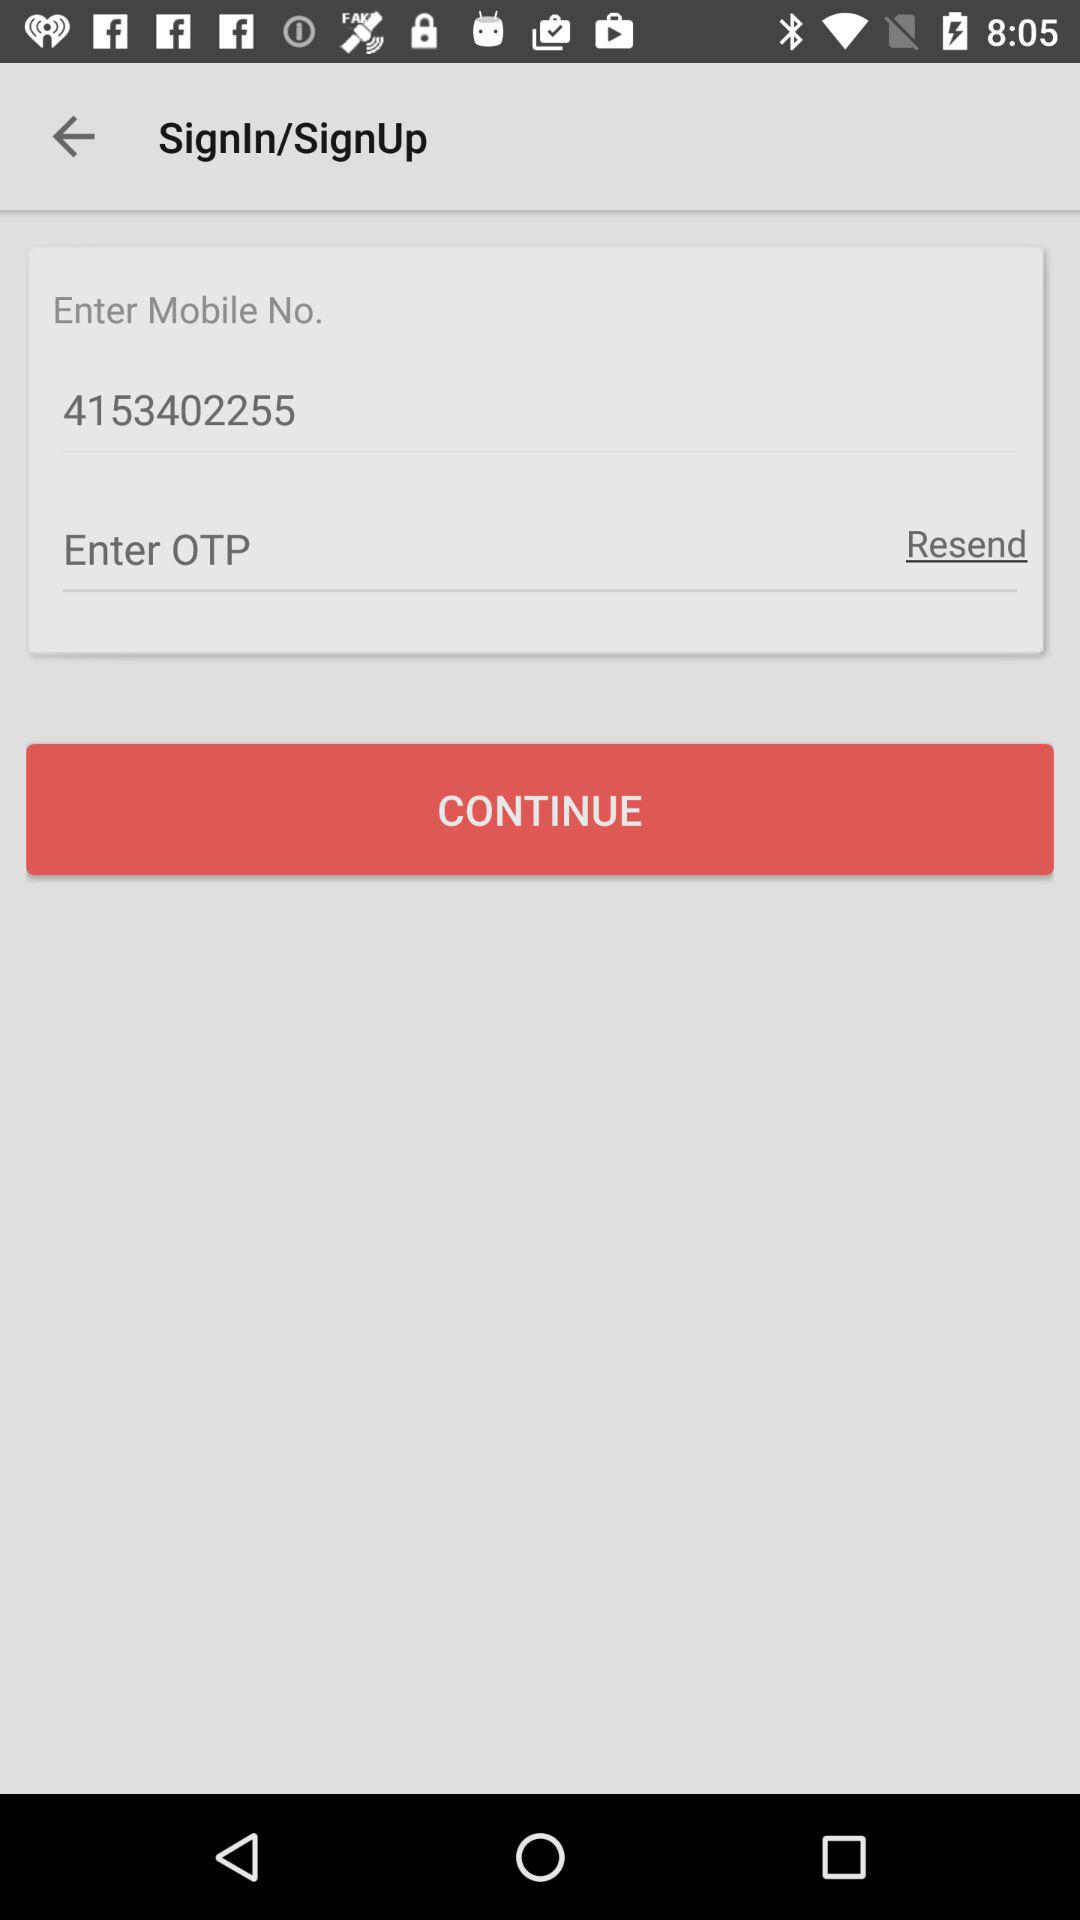What is the entered mobile number? The entered mobile number is 4153402255. 